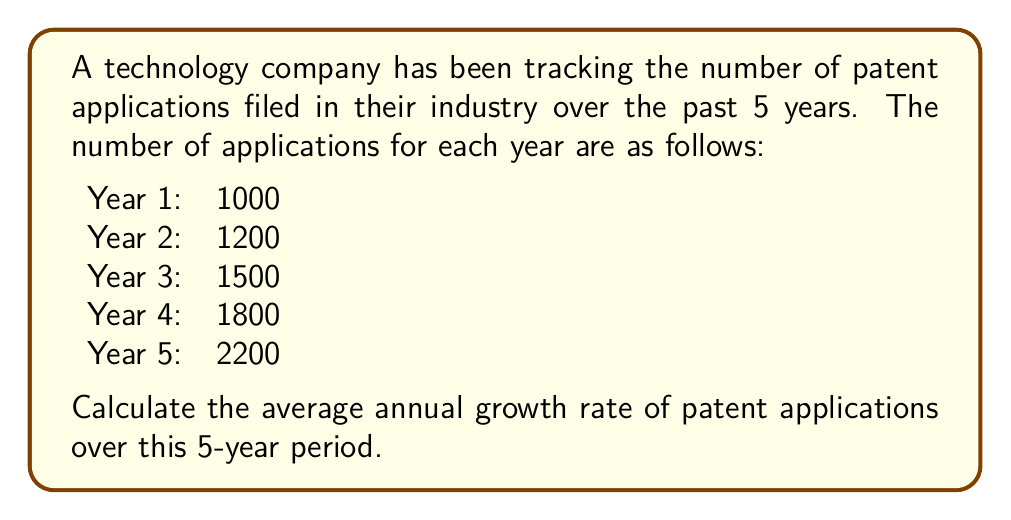Could you help me with this problem? To calculate the average annual growth rate, we'll use the compound annual growth rate (CAGR) formula:

$$ CAGR = \left(\frac{Ending Value}{Beginning Value}\right)^{\frac{1}{n}} - 1 $$

Where:
- Ending Value is the number of patent applications in Year 5
- Beginning Value is the number of patent applications in Year 1
- n is the number of years (5 in this case)

Step 1: Identify the values
- Ending Value = 2200
- Beginning Value = 1000
- n = 5

Step 2: Plug the values into the CAGR formula
$$ CAGR = \left(\frac{2200}{1000}\right)^{\frac{1}{5}} - 1 $$

Step 3: Simplify the fraction inside the parentheses
$$ CAGR = (2.2)^{\frac{1}{5}} - 1 $$

Step 4: Calculate the fifth root of 2.2
$$ CAGR = 1.17067 - 1 $$

Step 5: Subtract 1 and convert to a percentage
$$ CAGR = 0.17067 = 17.067\% $$

Therefore, the average annual growth rate of patent applications over the 5-year period is approximately 17.067%.
Answer: 17.067% 